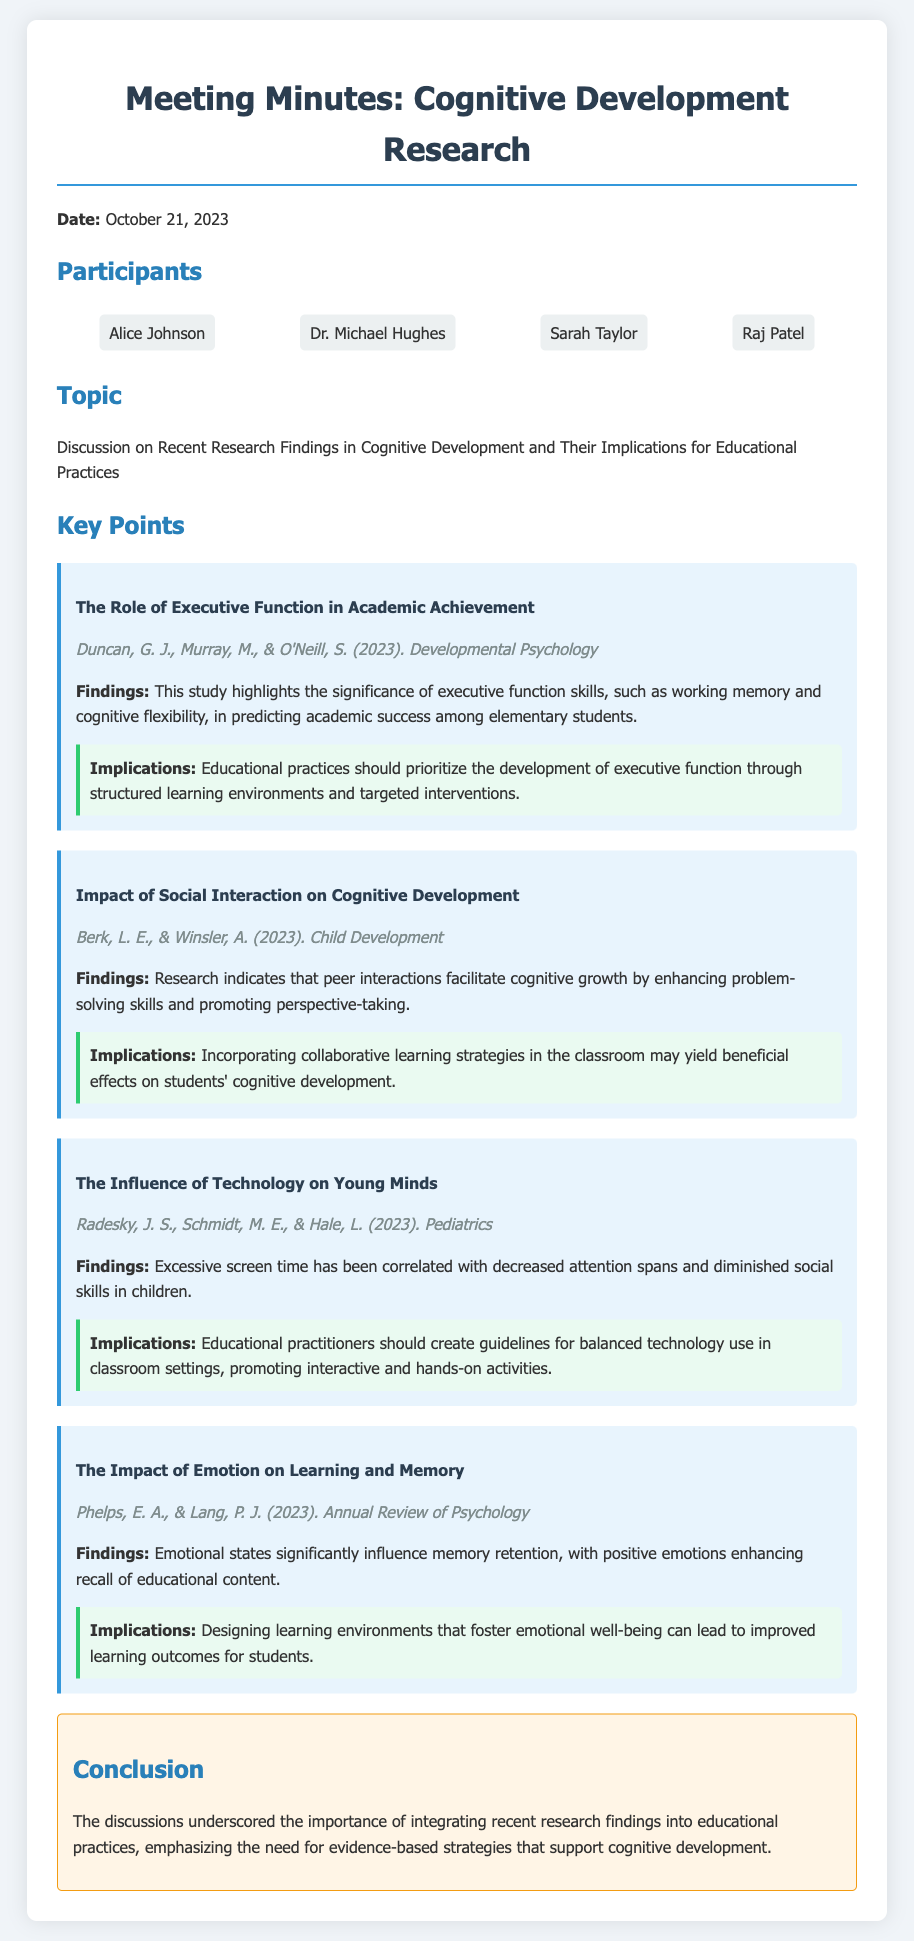what is the date of the meeting? The date of the meeting is explicitly stated in the document.
Answer: October 21, 2023 who authored the study on executive function? The authors of the study on executive function are mentioned in the key points section.
Answer: Duncan, G. J., Murray, M., & O'Neill, S what is one implication of the study on social interaction? The implications of the study on social interaction provide insights into educational practices.
Answer: Incorporating collaborative learning strategies what is the main finding of the study on technology's influence? The main finding regarding technology's influence is directly quoted in the document.
Answer: Excessive screen time has been correlated with decreased attention spans what emotional state enhances memory retention according to the findings? The study on emotion and learning specifies how emotional states affect memory retention.
Answer: Positive emotions what type of strategies should educational practitioners develop according to the technology study? The implications suggest specific strategies that educators need to consider regarding technology use.
Answer: Guidelines for balanced technology use how many participants were in the meeting? The document lists the participants involved in the discussion.
Answer: Four participants what is the focus of the discussion in the meeting? The focus of the meeting is clearly described in the topic section.
Answer: Recent Research Findings in Cognitive Development and Their Implications for Educational Practices who is one of the participants listed in the meeting? The document includes a list of participants involved in the meeting.
Answer: Alice Johnson 